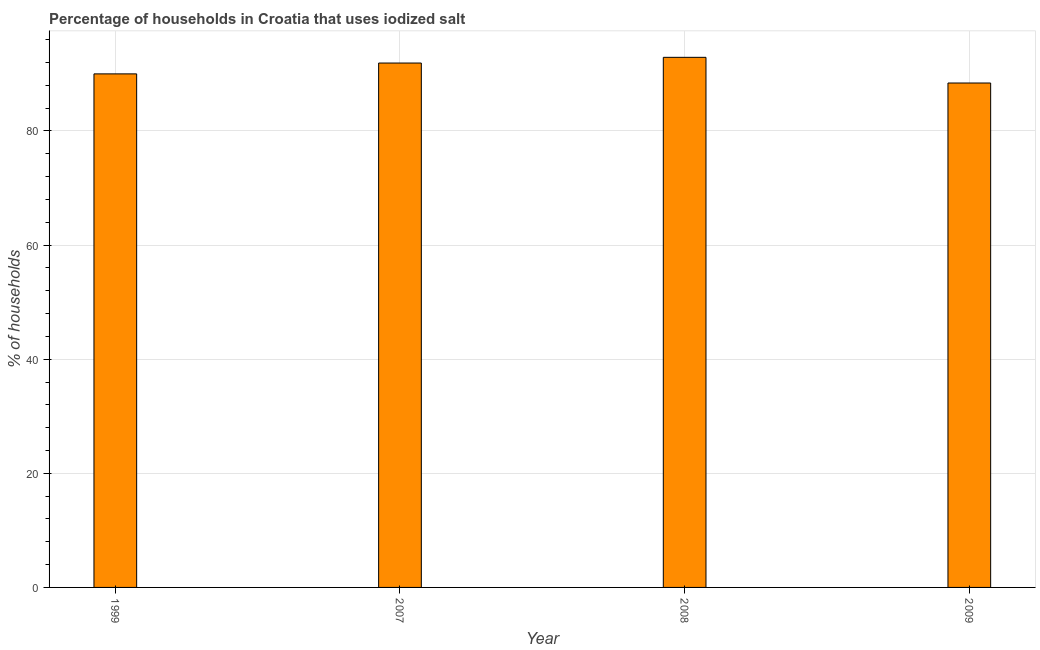Does the graph contain any zero values?
Offer a very short reply. No. Does the graph contain grids?
Give a very brief answer. Yes. What is the title of the graph?
Make the answer very short. Percentage of households in Croatia that uses iodized salt. What is the label or title of the Y-axis?
Your answer should be compact. % of households. Across all years, what is the maximum percentage of households where iodized salt is consumed?
Provide a succinct answer. 92.9. Across all years, what is the minimum percentage of households where iodized salt is consumed?
Your answer should be very brief. 88.4. In which year was the percentage of households where iodized salt is consumed minimum?
Make the answer very short. 2009. What is the sum of the percentage of households where iodized salt is consumed?
Provide a succinct answer. 363.2. What is the difference between the percentage of households where iodized salt is consumed in 1999 and 2008?
Your answer should be compact. -2.9. What is the average percentage of households where iodized salt is consumed per year?
Provide a succinct answer. 90.8. What is the median percentage of households where iodized salt is consumed?
Your response must be concise. 90.95. In how many years, is the percentage of households where iodized salt is consumed greater than 92 %?
Make the answer very short. 1. What is the ratio of the percentage of households where iodized salt is consumed in 1999 to that in 2009?
Keep it short and to the point. 1.02. Is the difference between the percentage of households where iodized salt is consumed in 1999 and 2007 greater than the difference between any two years?
Provide a succinct answer. No. What is the difference between the highest and the second highest percentage of households where iodized salt is consumed?
Offer a terse response. 1. Is the sum of the percentage of households where iodized salt is consumed in 2008 and 2009 greater than the maximum percentage of households where iodized salt is consumed across all years?
Offer a terse response. Yes. What is the difference between the highest and the lowest percentage of households where iodized salt is consumed?
Your response must be concise. 4.5. How many years are there in the graph?
Keep it short and to the point. 4. What is the difference between two consecutive major ticks on the Y-axis?
Provide a succinct answer. 20. Are the values on the major ticks of Y-axis written in scientific E-notation?
Make the answer very short. No. What is the % of households of 2007?
Ensure brevity in your answer.  91.9. What is the % of households in 2008?
Give a very brief answer. 92.9. What is the % of households of 2009?
Make the answer very short. 88.4. What is the difference between the % of households in 1999 and 2007?
Provide a succinct answer. -1.9. What is the difference between the % of households in 1999 and 2008?
Your response must be concise. -2.9. What is the difference between the % of households in 2007 and 2009?
Ensure brevity in your answer.  3.5. What is the ratio of the % of households in 1999 to that in 2007?
Your answer should be compact. 0.98. What is the ratio of the % of households in 1999 to that in 2009?
Provide a succinct answer. 1.02. What is the ratio of the % of households in 2007 to that in 2009?
Your response must be concise. 1.04. What is the ratio of the % of households in 2008 to that in 2009?
Provide a short and direct response. 1.05. 